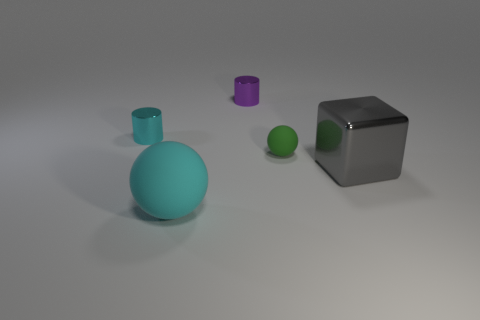Subtract all purple cylinders. How many cylinders are left? 1 Add 3 large shiny blocks. How many objects exist? 8 Subtract all blocks. How many objects are left? 4 Subtract all red blocks. Subtract all cyan cylinders. How many blocks are left? 1 Subtract all big brown matte cubes. Subtract all gray cubes. How many objects are left? 4 Add 3 large things. How many large things are left? 5 Add 4 big green shiny cubes. How many big green shiny cubes exist? 4 Subtract 0 green cylinders. How many objects are left? 5 